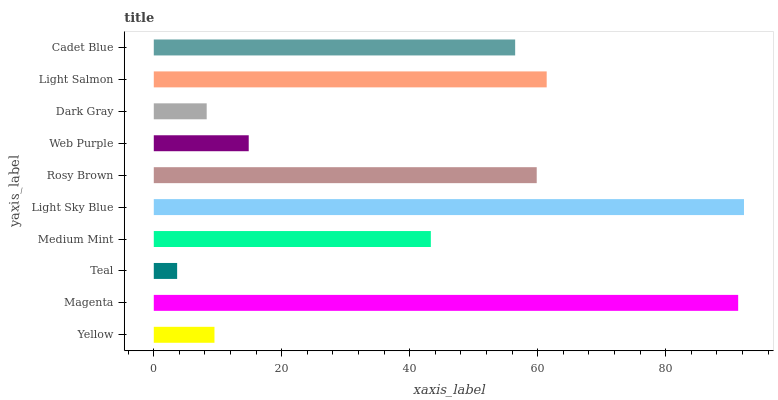Is Teal the minimum?
Answer yes or no. Yes. Is Light Sky Blue the maximum?
Answer yes or no. Yes. Is Magenta the minimum?
Answer yes or no. No. Is Magenta the maximum?
Answer yes or no. No. Is Magenta greater than Yellow?
Answer yes or no. Yes. Is Yellow less than Magenta?
Answer yes or no. Yes. Is Yellow greater than Magenta?
Answer yes or no. No. Is Magenta less than Yellow?
Answer yes or no. No. Is Cadet Blue the high median?
Answer yes or no. Yes. Is Medium Mint the low median?
Answer yes or no. Yes. Is Dark Gray the high median?
Answer yes or no. No. Is Yellow the low median?
Answer yes or no. No. 